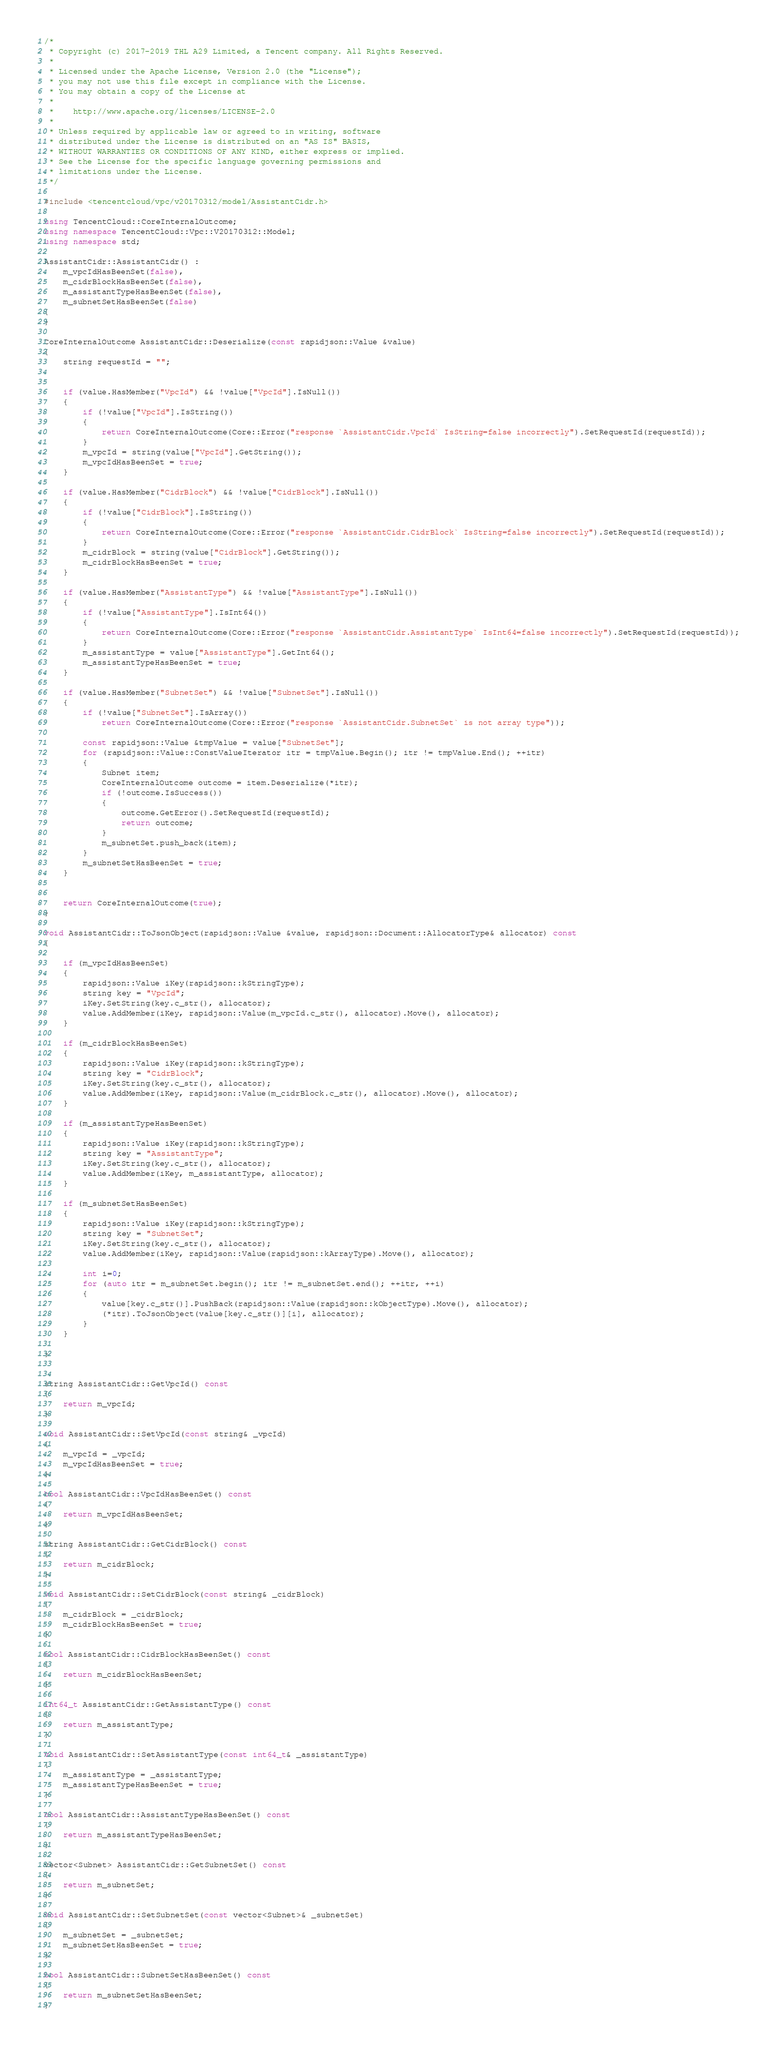Convert code to text. <code><loc_0><loc_0><loc_500><loc_500><_C++_>/*
 * Copyright (c) 2017-2019 THL A29 Limited, a Tencent company. All Rights Reserved.
 *
 * Licensed under the Apache License, Version 2.0 (the "License");
 * you may not use this file except in compliance with the License.
 * You may obtain a copy of the License at
 *
 *    http://www.apache.org/licenses/LICENSE-2.0
 *
 * Unless required by applicable law or agreed to in writing, software
 * distributed under the License is distributed on an "AS IS" BASIS,
 * WITHOUT WARRANTIES OR CONDITIONS OF ANY KIND, either express or implied.
 * See the License for the specific language governing permissions and
 * limitations under the License.
 */

#include <tencentcloud/vpc/v20170312/model/AssistantCidr.h>

using TencentCloud::CoreInternalOutcome;
using namespace TencentCloud::Vpc::V20170312::Model;
using namespace std;

AssistantCidr::AssistantCidr() :
    m_vpcIdHasBeenSet(false),
    m_cidrBlockHasBeenSet(false),
    m_assistantTypeHasBeenSet(false),
    m_subnetSetHasBeenSet(false)
{
}

CoreInternalOutcome AssistantCidr::Deserialize(const rapidjson::Value &value)
{
    string requestId = "";


    if (value.HasMember("VpcId") && !value["VpcId"].IsNull())
    {
        if (!value["VpcId"].IsString())
        {
            return CoreInternalOutcome(Core::Error("response `AssistantCidr.VpcId` IsString=false incorrectly").SetRequestId(requestId));
        }
        m_vpcId = string(value["VpcId"].GetString());
        m_vpcIdHasBeenSet = true;
    }

    if (value.HasMember("CidrBlock") && !value["CidrBlock"].IsNull())
    {
        if (!value["CidrBlock"].IsString())
        {
            return CoreInternalOutcome(Core::Error("response `AssistantCidr.CidrBlock` IsString=false incorrectly").SetRequestId(requestId));
        }
        m_cidrBlock = string(value["CidrBlock"].GetString());
        m_cidrBlockHasBeenSet = true;
    }

    if (value.HasMember("AssistantType") && !value["AssistantType"].IsNull())
    {
        if (!value["AssistantType"].IsInt64())
        {
            return CoreInternalOutcome(Core::Error("response `AssistantCidr.AssistantType` IsInt64=false incorrectly").SetRequestId(requestId));
        }
        m_assistantType = value["AssistantType"].GetInt64();
        m_assistantTypeHasBeenSet = true;
    }

    if (value.HasMember("SubnetSet") && !value["SubnetSet"].IsNull())
    {
        if (!value["SubnetSet"].IsArray())
            return CoreInternalOutcome(Core::Error("response `AssistantCidr.SubnetSet` is not array type"));

        const rapidjson::Value &tmpValue = value["SubnetSet"];
        for (rapidjson::Value::ConstValueIterator itr = tmpValue.Begin(); itr != tmpValue.End(); ++itr)
        {
            Subnet item;
            CoreInternalOutcome outcome = item.Deserialize(*itr);
            if (!outcome.IsSuccess())
            {
                outcome.GetError().SetRequestId(requestId);
                return outcome;
            }
            m_subnetSet.push_back(item);
        }
        m_subnetSetHasBeenSet = true;
    }


    return CoreInternalOutcome(true);
}

void AssistantCidr::ToJsonObject(rapidjson::Value &value, rapidjson::Document::AllocatorType& allocator) const
{

    if (m_vpcIdHasBeenSet)
    {
        rapidjson::Value iKey(rapidjson::kStringType);
        string key = "VpcId";
        iKey.SetString(key.c_str(), allocator);
        value.AddMember(iKey, rapidjson::Value(m_vpcId.c_str(), allocator).Move(), allocator);
    }

    if (m_cidrBlockHasBeenSet)
    {
        rapidjson::Value iKey(rapidjson::kStringType);
        string key = "CidrBlock";
        iKey.SetString(key.c_str(), allocator);
        value.AddMember(iKey, rapidjson::Value(m_cidrBlock.c_str(), allocator).Move(), allocator);
    }

    if (m_assistantTypeHasBeenSet)
    {
        rapidjson::Value iKey(rapidjson::kStringType);
        string key = "AssistantType";
        iKey.SetString(key.c_str(), allocator);
        value.AddMember(iKey, m_assistantType, allocator);
    }

    if (m_subnetSetHasBeenSet)
    {
        rapidjson::Value iKey(rapidjson::kStringType);
        string key = "SubnetSet";
        iKey.SetString(key.c_str(), allocator);
        value.AddMember(iKey, rapidjson::Value(rapidjson::kArrayType).Move(), allocator);

        int i=0;
        for (auto itr = m_subnetSet.begin(); itr != m_subnetSet.end(); ++itr, ++i)
        {
            value[key.c_str()].PushBack(rapidjson::Value(rapidjson::kObjectType).Move(), allocator);
            (*itr).ToJsonObject(value[key.c_str()][i], allocator);
        }
    }

}


string AssistantCidr::GetVpcId() const
{
    return m_vpcId;
}

void AssistantCidr::SetVpcId(const string& _vpcId)
{
    m_vpcId = _vpcId;
    m_vpcIdHasBeenSet = true;
}

bool AssistantCidr::VpcIdHasBeenSet() const
{
    return m_vpcIdHasBeenSet;
}

string AssistantCidr::GetCidrBlock() const
{
    return m_cidrBlock;
}

void AssistantCidr::SetCidrBlock(const string& _cidrBlock)
{
    m_cidrBlock = _cidrBlock;
    m_cidrBlockHasBeenSet = true;
}

bool AssistantCidr::CidrBlockHasBeenSet() const
{
    return m_cidrBlockHasBeenSet;
}

int64_t AssistantCidr::GetAssistantType() const
{
    return m_assistantType;
}

void AssistantCidr::SetAssistantType(const int64_t& _assistantType)
{
    m_assistantType = _assistantType;
    m_assistantTypeHasBeenSet = true;
}

bool AssistantCidr::AssistantTypeHasBeenSet() const
{
    return m_assistantTypeHasBeenSet;
}

vector<Subnet> AssistantCidr::GetSubnetSet() const
{
    return m_subnetSet;
}

void AssistantCidr::SetSubnetSet(const vector<Subnet>& _subnetSet)
{
    m_subnetSet = _subnetSet;
    m_subnetSetHasBeenSet = true;
}

bool AssistantCidr::SubnetSetHasBeenSet() const
{
    return m_subnetSetHasBeenSet;
}

</code> 